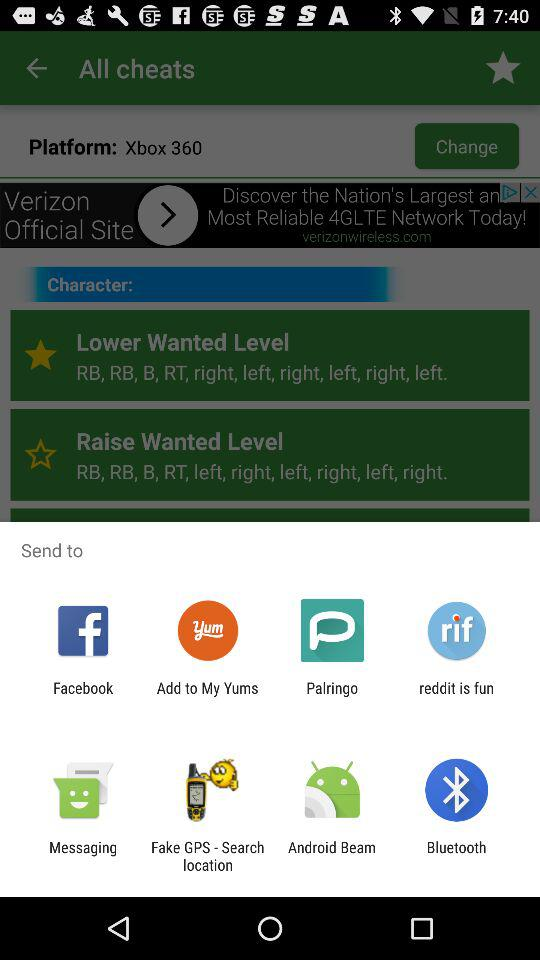What application can be chosen to share? The applications that can be choosed to share are "Facebook", "Add to My Yums", "Palringo", "reddit is fun", "Messaging", "Fake GPS - Search location", "Android Beam" and "Bluetooth". 